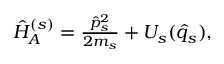Convert formula to latex. <formula><loc_0><loc_0><loc_500><loc_500>\begin{array} { r } { \hat { H } _ { A } ^ { ( s ) } = \frac { \hat { p } _ { s } ^ { 2 } } { 2 m _ { s } } + U _ { s } ( \hat { q } _ { s } ) , } \end{array}</formula> 